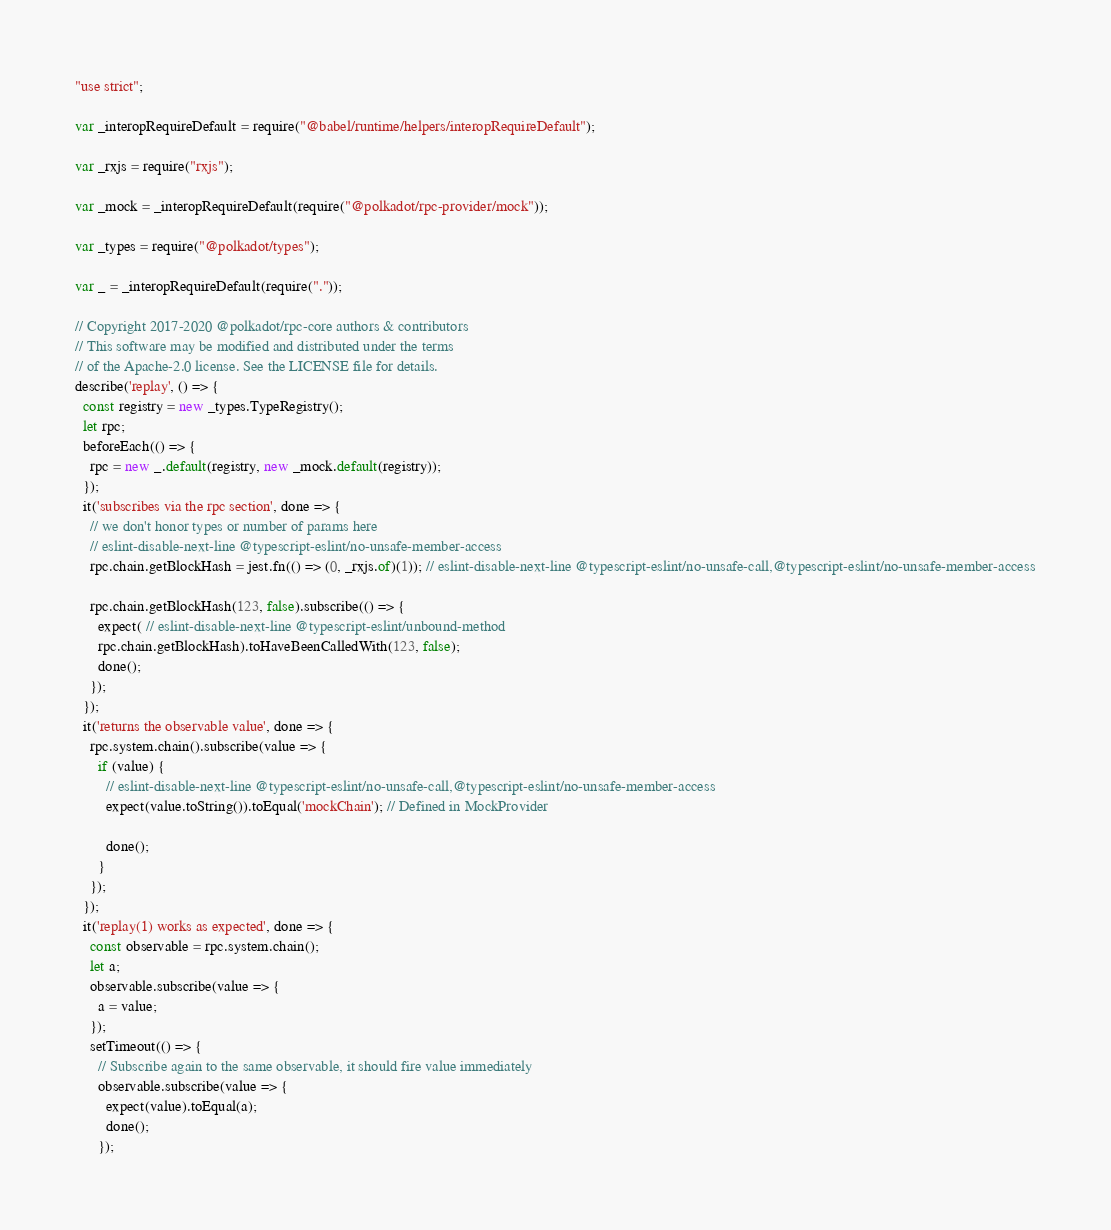<code> <loc_0><loc_0><loc_500><loc_500><_JavaScript_>"use strict";

var _interopRequireDefault = require("@babel/runtime/helpers/interopRequireDefault");

var _rxjs = require("rxjs");

var _mock = _interopRequireDefault(require("@polkadot/rpc-provider/mock"));

var _types = require("@polkadot/types");

var _ = _interopRequireDefault(require("."));

// Copyright 2017-2020 @polkadot/rpc-core authors & contributors
// This software may be modified and distributed under the terms
// of the Apache-2.0 license. See the LICENSE file for details.
describe('replay', () => {
  const registry = new _types.TypeRegistry();
  let rpc;
  beforeEach(() => {
    rpc = new _.default(registry, new _mock.default(registry));
  });
  it('subscribes via the rpc section', done => {
    // we don't honor types or number of params here
    // eslint-disable-next-line @typescript-eslint/no-unsafe-member-access
    rpc.chain.getBlockHash = jest.fn(() => (0, _rxjs.of)(1)); // eslint-disable-next-line @typescript-eslint/no-unsafe-call,@typescript-eslint/no-unsafe-member-access

    rpc.chain.getBlockHash(123, false).subscribe(() => {
      expect( // eslint-disable-next-line @typescript-eslint/unbound-method
      rpc.chain.getBlockHash).toHaveBeenCalledWith(123, false);
      done();
    });
  });
  it('returns the observable value', done => {
    rpc.system.chain().subscribe(value => {
      if (value) {
        // eslint-disable-next-line @typescript-eslint/no-unsafe-call,@typescript-eslint/no-unsafe-member-access
        expect(value.toString()).toEqual('mockChain'); // Defined in MockProvider

        done();
      }
    });
  });
  it('replay(1) works as expected', done => {
    const observable = rpc.system.chain();
    let a;
    observable.subscribe(value => {
      a = value;
    });
    setTimeout(() => {
      // Subscribe again to the same observable, it should fire value immediately
      observable.subscribe(value => {
        expect(value).toEqual(a);
        done();
      });</code> 